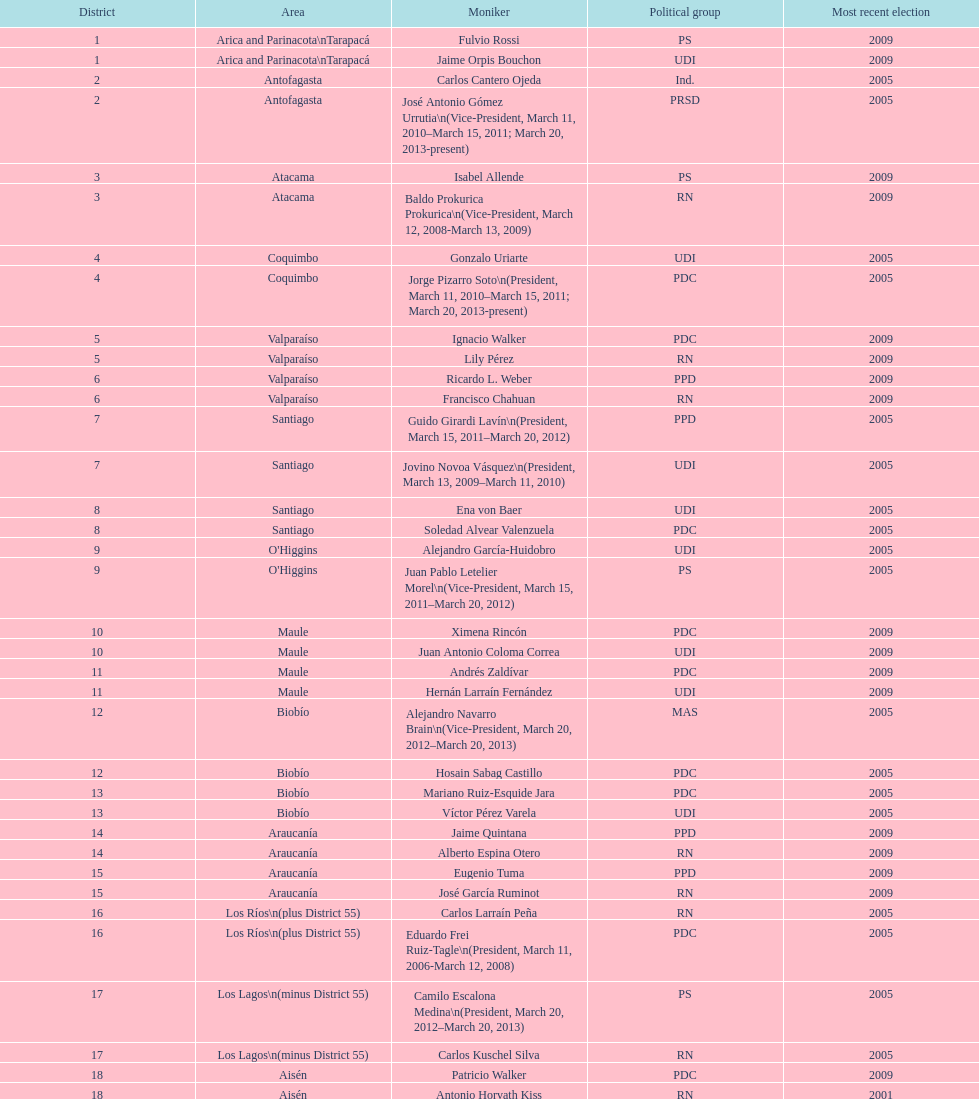Which region is listed below atacama? Coquimbo. 